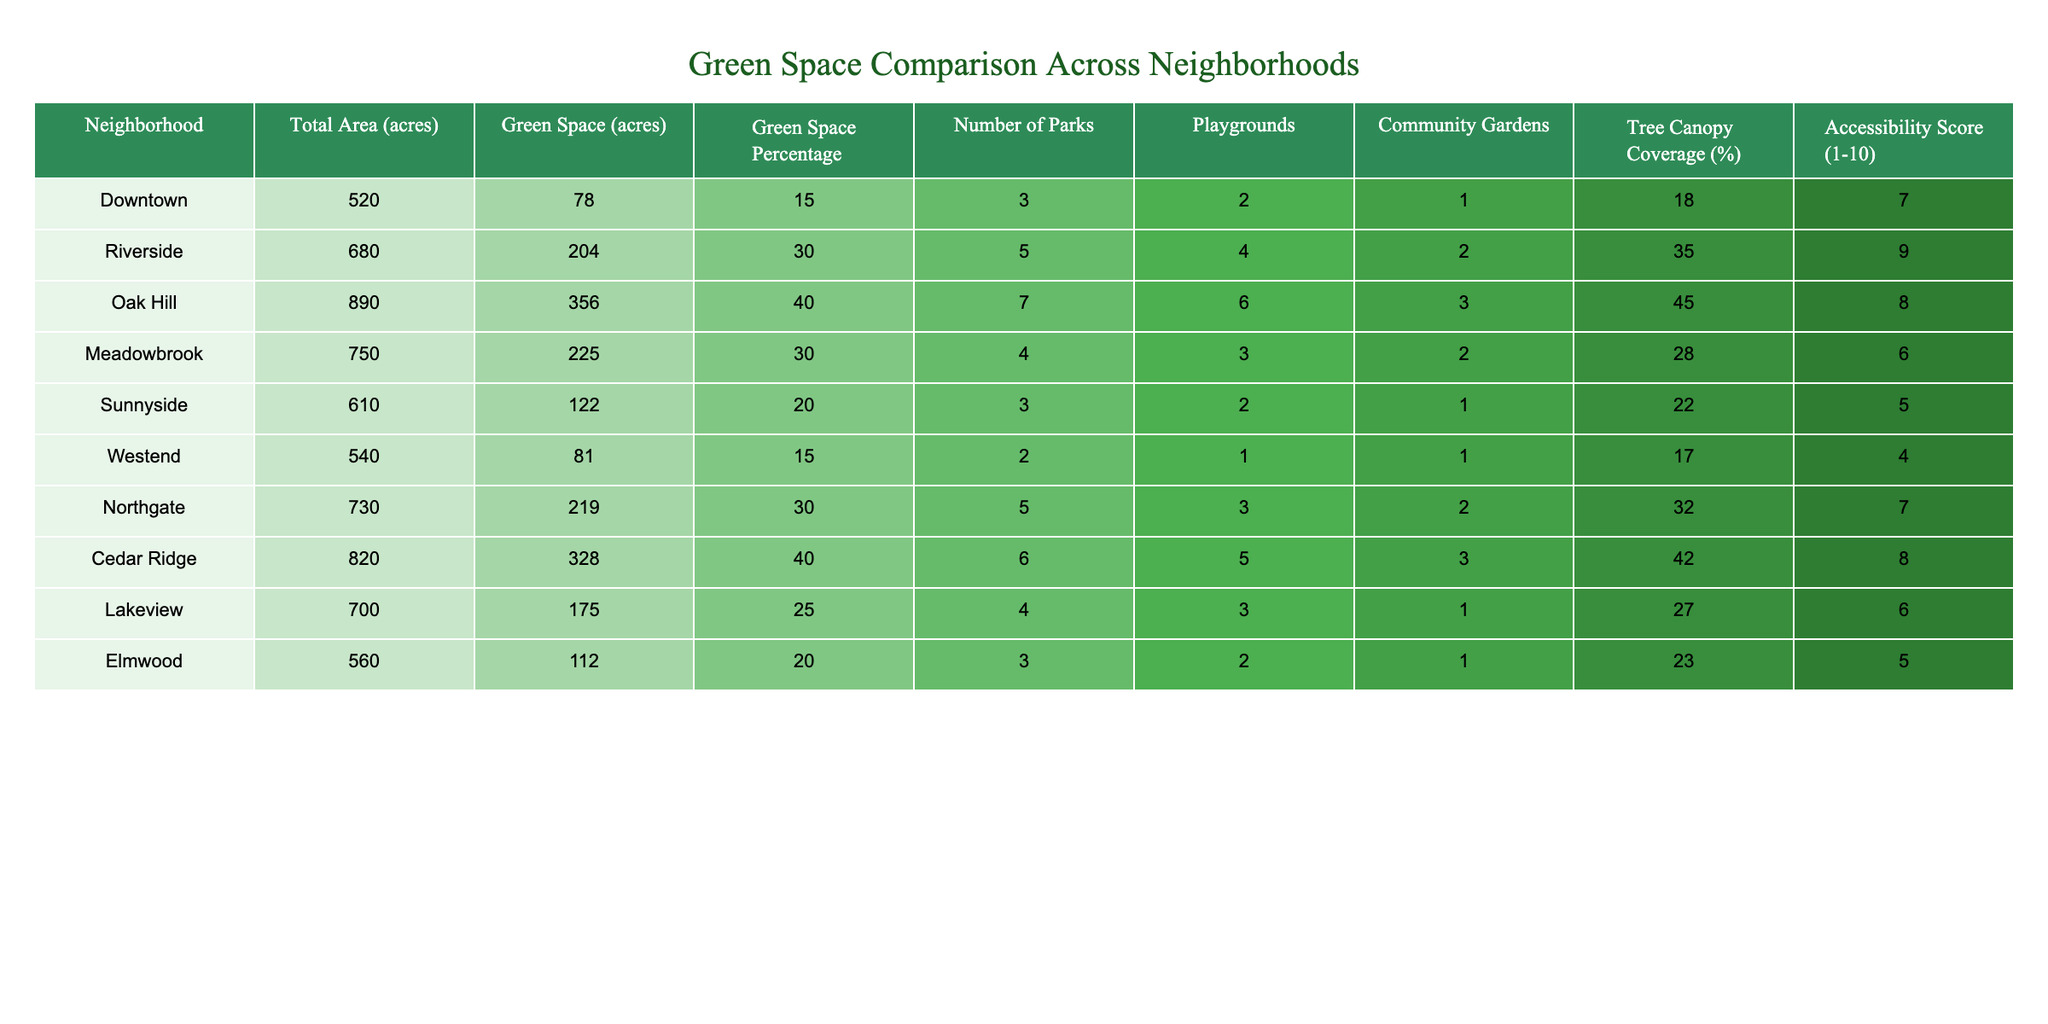What is the total area of the Riverside neighborhood? From the table, the 'Total Area (acres)' for Riverside is listed as 680 acres.
Answer: 680 acres Which neighborhood has the highest percentage of green space? By looking at the 'Green Space Percentage' column, Oak Hill and Cedar Ridge both have the highest percentage of 40%.
Answer: Oak Hill and Cedar Ridge How many parks are there in the Meadowbrook neighborhood? The data shows that Meadowbrook has 4 parks listed in the 'Number of Parks' column.
Answer: 4 parks What is the average green space percentage across all neighborhoods? The green space percentages are 15, 30, 40, 30, 20, 15, 30, 40, 25, and 20. Summing these gives  300; then dividing by 10 (the number of neighborhoods) gives an average of 30%.
Answer: 30% Is it true that the Westend neighborhood has more tree canopy coverage than the Downtown neighborhood? The table indicates that Westend has 17% tree canopy coverage, while Downtown has only 18%, therefore, it is not true.
Answer: No What is the total number of community gardens across all neighborhoods? Adding the community gardens from all neighborhoods (1 + 2 + 3 + 2 + 1 + 1 + 2 + 3 + 1 + 1) totals to 17 community gardens.
Answer: 17 community gardens Which neighborhood has the lowest accessibility score, and what is that score? Westend has the lowest accessibility score recorded as 4 in the 'Accessibility Score (1-10)' column.
Answer: Westend, score 4 How does the green space per acre compare between Lakeview and Oak Hill? Lakeview has 175 acres of green space out of 700 acres total, making it 25% green space. Oak Hill has 356 acres out of 890 acres, resulting in 40%. Therefore, Oak Hill has a better green space per acre ratio.
Answer: Oak Hill is better Which neighborhoods have an accessibility score of 7 or higher, and how many are there? The neighborhoods with an accessibility score of 7 or higher are Riverside, Northgate, and Downtown—making a total of 3 neighborhoods.
Answer: 3 neighborhoods 